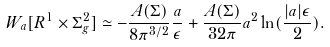<formula> <loc_0><loc_0><loc_500><loc_500>W _ { a } [ R ^ { 1 } \times \Sigma _ { g } ^ { 2 } ] \simeq - \frac { A ( \Sigma ) } { 8 \pi ^ { 3 / 2 } } \frac { a } { \epsilon } + \frac { A ( \Sigma ) } { 3 2 \pi } a ^ { 2 } \ln ( \frac { | a | \epsilon } { 2 } ) .</formula> 